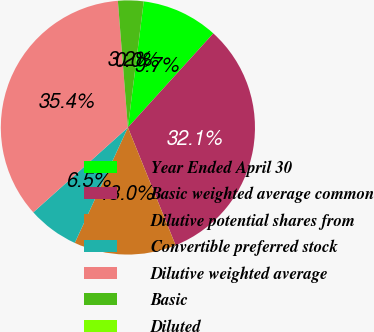Convert chart to OTSL. <chart><loc_0><loc_0><loc_500><loc_500><pie_chart><fcel>Year Ended April 30<fcel>Basic weighted average common<fcel>Dilutive potential shares from<fcel>Convertible preferred stock<fcel>Dilutive weighted average<fcel>Basic<fcel>Diluted<nl><fcel>9.74%<fcel>32.14%<fcel>12.99%<fcel>6.5%<fcel>35.38%<fcel>3.25%<fcel>0.0%<nl></chart> 